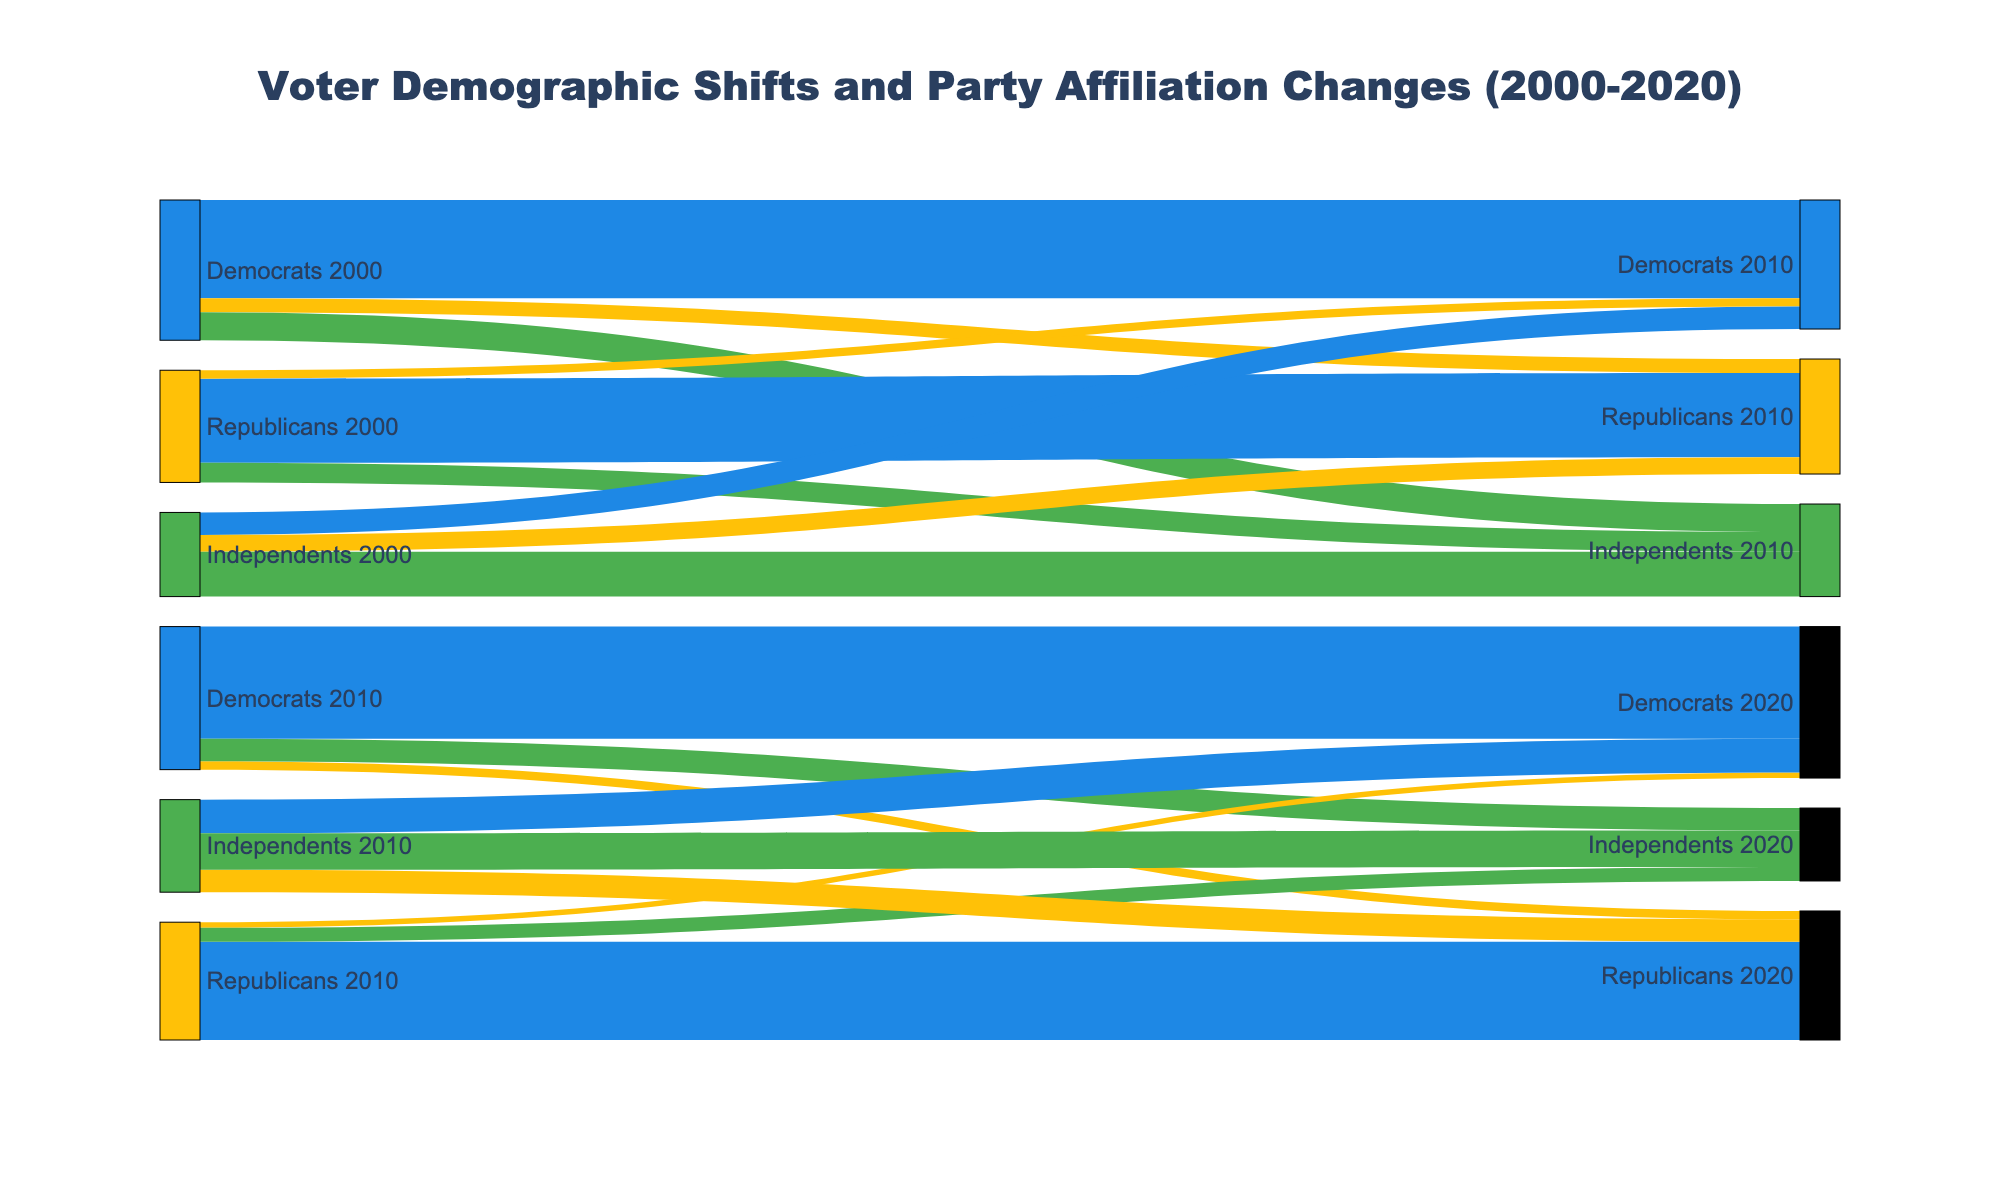How many people remained Democrats from 2000 to 2010? Refer to the Sankey flow showing the path from "Democrats 2000" to "Democrats 2010." The value at this path is 35,000,000.
Answer: 35,000,000 How many Independents switched to the Democratic party from 2010 to 2020? Refer to the Sankey flow showing the path from "Independents 2010" to "Democrats 2020." The value at this path is 12,000,000.
Answer: 12,000,000 What is the total number of people that identified as Independents in 2010? Sum the values of all flows leading to "Independents 2010." Those flows are "Democrats 2000" to "Independents 2010" (10,000,000), "Republicans 2000" to "Independents 2010" (7,000,000), and "Independents 2000" to "Independents 2010" (16,000,000). Therefore, 10,000,000 + 7,000,000 + 16,000,000 = 33,000,000.
Answer: 33,000,000 Which group in 2010 saw the largest exodus to Independents in 2020? Compare the values of the flows leading to "Independents 2020" from each group in 2010. These are "Democrats 2010" to "Independents 2020" (8,000,000), "Republicans 2010" to "Independents 2020" (5,000,000), and "Independents 2010" to "Independents 2020" (13,000,000). The highest value is 13,000,000 from "Independents 2010."
Answer: Independents 2010 How did the number of Republicans change from 2000 to 2020? Identify the initial and final counts for Republicans. From "Republicans 2000" to other groups in 2010: 30,000,000 remained Republicans, 3,000,000 switched to Democrats, and 7,000,000 became Independents. Summing up, the initial Republican population was 40,000,000. In 2020, 35,000,000 remained Republicans, 2,000,000 became Democrats, and 5,000,000 became Independents. Summing up, the final population is 42,000,000. There is an increase of 2,000,000.
Answer: Increased by 2,000,000 What's the proportion of Democrats that remained Democrats from 2010 to 2020? Calculate the ratio of Democrats that remained Democrats from 2010 to 2020, out of the total Democrats in 2010. From "Democrats 2010" to "Democrats 2020" is 40,000,000. The total Democrats in 2010 is the sum of all Democrats in 2010 paths: 40,000,000 (to Democrats 2020) + 3,000,000 (to Republicans 2020) + 8,000,000 (to Independents 2020) = 51,000,000. So, the ratio is 40,000,000 / 51,000,000 = 0.7843, or 78.43%.
Answer: 78.43% How many people switched from being Republicans in 2000 to Democrats by 2020? Track the flow from "Republicans 2000" transitioning to "Democrats 2010" first, and then to "Democrats 2020." This path involves 3,000,000 people from "Republicans 2000" to "Democrats 2010" and 2,000,000 people from "Republicans 2010" to "Democrats 2020."
Answer: 2,000,000 How did the number of Independents change from 2000 to 2020? Calculate the initial and final counts for Independents. From "Independents 2000" to other groups in 2010: 16,000,000 remained Independents, 8,000,000 became Democrats, and 6,000,000 became Republicans, summing to an initial population of 30,000,000. In 2020, 13,000,000 remained Independents, 12,000,000 became Democrats, and 8,000,000 became Republicans, summing to a final population of 33,000,000. The population increased by 3,000,000.
Answer: Increased by 3,000,000 Which group in 2000 had the highest retention rate for 2010? Calculate the retention rate for each group in 2000. Democrats retained 35,000,000 of 50,000,000 (70%), Republicans retained 30,000,000 of 40,000,000 (75%), and Independents retained 16,000,000 of 30,000,000 (53.33%). The highest retention rate is for Republicans with 75%.
Answer: Republicans How many people identified as Democrats in 2020 but were not Democrats in 2000? Sum the contributions to "Democrats 2020" from groups other than "Democrats 2000." These contributions are from "Republicans 2010" (2,000,000) and "Independents 2010" (12,000,000). Total is 2,000,000 + 12,000,000 = 14,000,000.
Answer: 14,000,000 